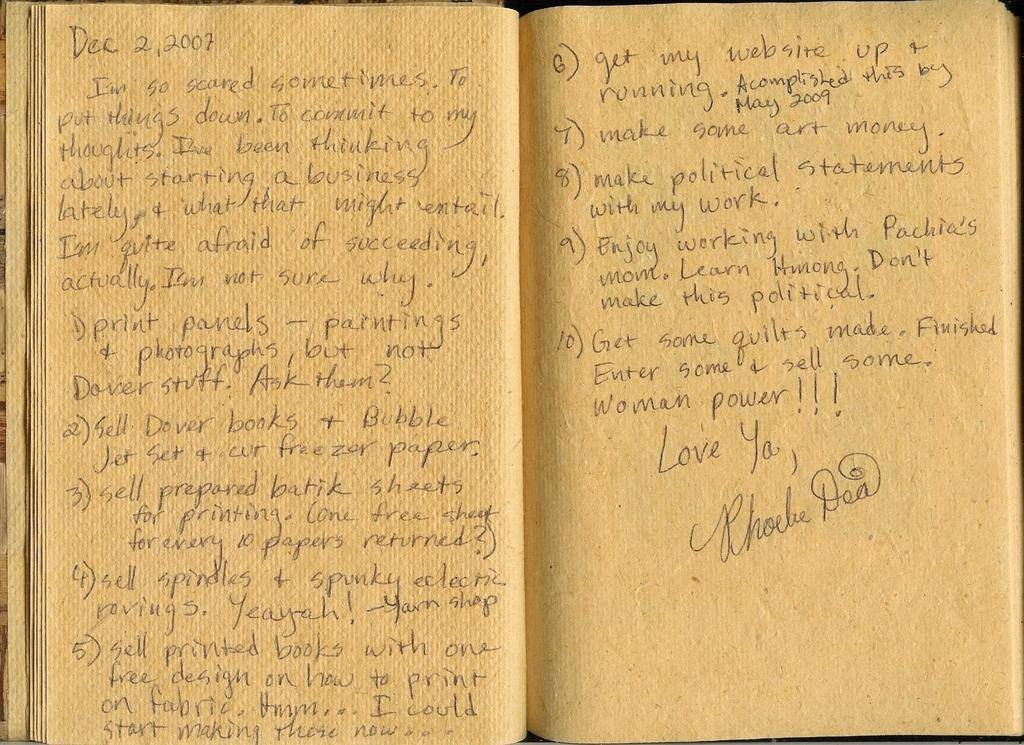<image>
Summarize the visual content of the image. Journal that starts off with the date on 2007. 